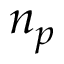Convert formula to latex. <formula><loc_0><loc_0><loc_500><loc_500>n _ { p }</formula> 